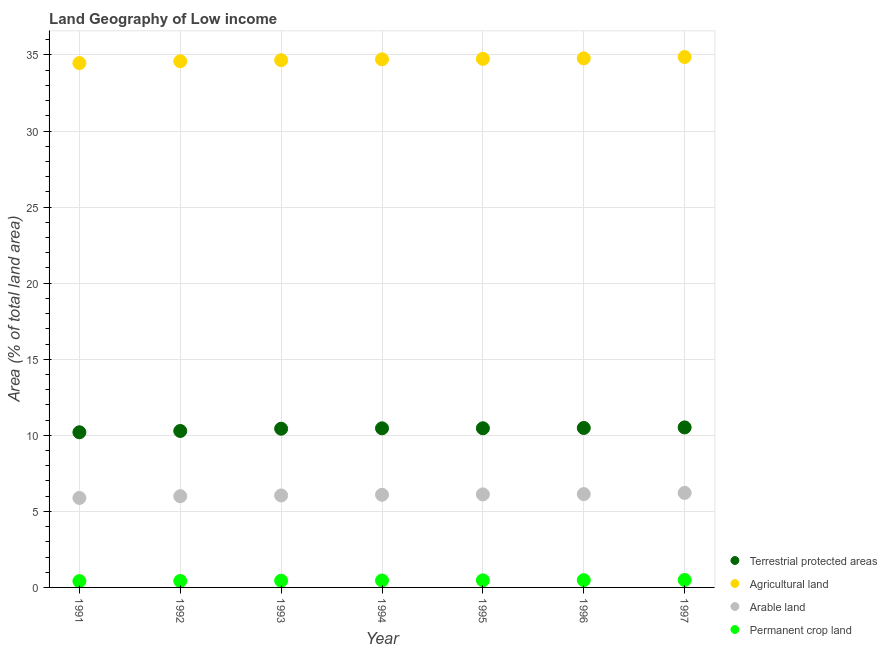How many different coloured dotlines are there?
Provide a short and direct response. 4. Is the number of dotlines equal to the number of legend labels?
Make the answer very short. Yes. What is the percentage of area under permanent crop land in 1996?
Make the answer very short. 0.48. Across all years, what is the maximum percentage of land under terrestrial protection?
Keep it short and to the point. 10.52. Across all years, what is the minimum percentage of area under permanent crop land?
Make the answer very short. 0.41. In which year was the percentage of land under terrestrial protection maximum?
Offer a very short reply. 1997. In which year was the percentage of area under arable land minimum?
Provide a short and direct response. 1991. What is the total percentage of area under permanent crop land in the graph?
Your response must be concise. 3.17. What is the difference between the percentage of land under terrestrial protection in 1992 and that in 1997?
Offer a terse response. -0.23. What is the difference between the percentage of area under permanent crop land in 1991 and the percentage of area under arable land in 1995?
Make the answer very short. -5.7. What is the average percentage of area under arable land per year?
Offer a terse response. 6.07. In the year 1991, what is the difference between the percentage of land under terrestrial protection and percentage of area under permanent crop land?
Your answer should be very brief. 9.78. In how many years, is the percentage of area under arable land greater than 14 %?
Your answer should be very brief. 0. What is the ratio of the percentage of area under agricultural land in 1992 to that in 1994?
Your answer should be very brief. 1. Is the difference between the percentage of area under arable land in 1994 and 1995 greater than the difference between the percentage of land under terrestrial protection in 1994 and 1995?
Offer a terse response. No. What is the difference between the highest and the second highest percentage of area under permanent crop land?
Provide a short and direct response. 0.01. What is the difference between the highest and the lowest percentage of area under agricultural land?
Offer a terse response. 0.4. In how many years, is the percentage of area under arable land greater than the average percentage of area under arable land taken over all years?
Give a very brief answer. 4. Is it the case that in every year, the sum of the percentage of land under terrestrial protection and percentage of area under arable land is greater than the sum of percentage of area under agricultural land and percentage of area under permanent crop land?
Keep it short and to the point. No. Does the percentage of area under arable land monotonically increase over the years?
Provide a short and direct response. Yes. How many years are there in the graph?
Keep it short and to the point. 7. What is the difference between two consecutive major ticks on the Y-axis?
Ensure brevity in your answer.  5. Are the values on the major ticks of Y-axis written in scientific E-notation?
Your response must be concise. No. How are the legend labels stacked?
Your response must be concise. Vertical. What is the title of the graph?
Your answer should be compact. Land Geography of Low income. What is the label or title of the X-axis?
Offer a very short reply. Year. What is the label or title of the Y-axis?
Ensure brevity in your answer.  Area (% of total land area). What is the Area (% of total land area) in Terrestrial protected areas in 1991?
Provide a short and direct response. 10.2. What is the Area (% of total land area) of Agricultural land in 1991?
Ensure brevity in your answer.  34.47. What is the Area (% of total land area) of Arable land in 1991?
Your response must be concise. 5.88. What is the Area (% of total land area) of Permanent crop land in 1991?
Ensure brevity in your answer.  0.41. What is the Area (% of total land area) in Terrestrial protected areas in 1992?
Keep it short and to the point. 10.28. What is the Area (% of total land area) in Agricultural land in 1992?
Keep it short and to the point. 34.59. What is the Area (% of total land area) in Arable land in 1992?
Your answer should be compact. 6. What is the Area (% of total land area) in Permanent crop land in 1992?
Ensure brevity in your answer.  0.42. What is the Area (% of total land area) in Terrestrial protected areas in 1993?
Keep it short and to the point. 10.43. What is the Area (% of total land area) of Agricultural land in 1993?
Make the answer very short. 34.66. What is the Area (% of total land area) of Arable land in 1993?
Your answer should be compact. 6.04. What is the Area (% of total land area) of Permanent crop land in 1993?
Your response must be concise. 0.44. What is the Area (% of total land area) of Terrestrial protected areas in 1994?
Offer a very short reply. 10.46. What is the Area (% of total land area) of Agricultural land in 1994?
Your response must be concise. 34.71. What is the Area (% of total land area) of Arable land in 1994?
Your response must be concise. 6.09. What is the Area (% of total land area) of Permanent crop land in 1994?
Your answer should be very brief. 0.46. What is the Area (% of total land area) in Terrestrial protected areas in 1995?
Your response must be concise. 10.46. What is the Area (% of total land area) of Agricultural land in 1995?
Your response must be concise. 34.74. What is the Area (% of total land area) in Arable land in 1995?
Offer a terse response. 6.11. What is the Area (% of total land area) of Permanent crop land in 1995?
Provide a succinct answer. 0.47. What is the Area (% of total land area) of Terrestrial protected areas in 1996?
Give a very brief answer. 10.48. What is the Area (% of total land area) in Agricultural land in 1996?
Give a very brief answer. 34.77. What is the Area (% of total land area) of Arable land in 1996?
Make the answer very short. 6.13. What is the Area (% of total land area) of Permanent crop land in 1996?
Offer a terse response. 0.48. What is the Area (% of total land area) of Terrestrial protected areas in 1997?
Your answer should be compact. 10.52. What is the Area (% of total land area) of Agricultural land in 1997?
Keep it short and to the point. 34.86. What is the Area (% of total land area) in Arable land in 1997?
Your answer should be very brief. 6.21. What is the Area (% of total land area) in Permanent crop land in 1997?
Make the answer very short. 0.49. Across all years, what is the maximum Area (% of total land area) of Terrestrial protected areas?
Offer a very short reply. 10.52. Across all years, what is the maximum Area (% of total land area) of Agricultural land?
Give a very brief answer. 34.86. Across all years, what is the maximum Area (% of total land area) in Arable land?
Offer a terse response. 6.21. Across all years, what is the maximum Area (% of total land area) in Permanent crop land?
Give a very brief answer. 0.49. Across all years, what is the minimum Area (% of total land area) of Terrestrial protected areas?
Ensure brevity in your answer.  10.2. Across all years, what is the minimum Area (% of total land area) in Agricultural land?
Make the answer very short. 34.47. Across all years, what is the minimum Area (% of total land area) of Arable land?
Offer a very short reply. 5.88. Across all years, what is the minimum Area (% of total land area) of Permanent crop land?
Give a very brief answer. 0.41. What is the total Area (% of total land area) of Terrestrial protected areas in the graph?
Ensure brevity in your answer.  72.84. What is the total Area (% of total land area) of Agricultural land in the graph?
Ensure brevity in your answer.  242.81. What is the total Area (% of total land area) of Arable land in the graph?
Your answer should be compact. 42.48. What is the total Area (% of total land area) in Permanent crop land in the graph?
Offer a terse response. 3.17. What is the difference between the Area (% of total land area) of Terrestrial protected areas in 1991 and that in 1992?
Make the answer very short. -0.09. What is the difference between the Area (% of total land area) in Agricultural land in 1991 and that in 1992?
Give a very brief answer. -0.12. What is the difference between the Area (% of total land area) in Arable land in 1991 and that in 1992?
Provide a succinct answer. -0.11. What is the difference between the Area (% of total land area) in Permanent crop land in 1991 and that in 1992?
Offer a very short reply. -0.01. What is the difference between the Area (% of total land area) of Terrestrial protected areas in 1991 and that in 1993?
Give a very brief answer. -0.23. What is the difference between the Area (% of total land area) of Agricultural land in 1991 and that in 1993?
Ensure brevity in your answer.  -0.19. What is the difference between the Area (% of total land area) of Arable land in 1991 and that in 1993?
Provide a short and direct response. -0.16. What is the difference between the Area (% of total land area) of Permanent crop land in 1991 and that in 1993?
Your answer should be compact. -0.03. What is the difference between the Area (% of total land area) in Terrestrial protected areas in 1991 and that in 1994?
Make the answer very short. -0.26. What is the difference between the Area (% of total land area) in Agricultural land in 1991 and that in 1994?
Your answer should be compact. -0.25. What is the difference between the Area (% of total land area) in Arable land in 1991 and that in 1994?
Your answer should be compact. -0.21. What is the difference between the Area (% of total land area) in Permanent crop land in 1991 and that in 1994?
Your answer should be compact. -0.04. What is the difference between the Area (% of total land area) in Terrestrial protected areas in 1991 and that in 1995?
Offer a very short reply. -0.26. What is the difference between the Area (% of total land area) of Agricultural land in 1991 and that in 1995?
Give a very brief answer. -0.28. What is the difference between the Area (% of total land area) in Arable land in 1991 and that in 1995?
Keep it short and to the point. -0.23. What is the difference between the Area (% of total land area) in Permanent crop land in 1991 and that in 1995?
Your answer should be very brief. -0.05. What is the difference between the Area (% of total land area) of Terrestrial protected areas in 1991 and that in 1996?
Offer a terse response. -0.28. What is the difference between the Area (% of total land area) of Agricultural land in 1991 and that in 1996?
Provide a short and direct response. -0.31. What is the difference between the Area (% of total land area) of Arable land in 1991 and that in 1996?
Make the answer very short. -0.25. What is the difference between the Area (% of total land area) of Permanent crop land in 1991 and that in 1996?
Ensure brevity in your answer.  -0.06. What is the difference between the Area (% of total land area) of Terrestrial protected areas in 1991 and that in 1997?
Give a very brief answer. -0.32. What is the difference between the Area (% of total land area) of Agricultural land in 1991 and that in 1997?
Your response must be concise. -0.4. What is the difference between the Area (% of total land area) of Arable land in 1991 and that in 1997?
Your response must be concise. -0.33. What is the difference between the Area (% of total land area) of Permanent crop land in 1991 and that in 1997?
Give a very brief answer. -0.07. What is the difference between the Area (% of total land area) of Terrestrial protected areas in 1992 and that in 1993?
Keep it short and to the point. -0.15. What is the difference between the Area (% of total land area) of Agricultural land in 1992 and that in 1993?
Offer a very short reply. -0.07. What is the difference between the Area (% of total land area) of Arable land in 1992 and that in 1993?
Your response must be concise. -0.05. What is the difference between the Area (% of total land area) in Permanent crop land in 1992 and that in 1993?
Offer a very short reply. -0.02. What is the difference between the Area (% of total land area) of Terrestrial protected areas in 1992 and that in 1994?
Keep it short and to the point. -0.17. What is the difference between the Area (% of total land area) of Agricultural land in 1992 and that in 1994?
Provide a succinct answer. -0.13. What is the difference between the Area (% of total land area) of Arable land in 1992 and that in 1994?
Offer a very short reply. -0.1. What is the difference between the Area (% of total land area) of Permanent crop land in 1992 and that in 1994?
Offer a terse response. -0.03. What is the difference between the Area (% of total land area) of Terrestrial protected areas in 1992 and that in 1995?
Keep it short and to the point. -0.18. What is the difference between the Area (% of total land area) in Agricultural land in 1992 and that in 1995?
Provide a succinct answer. -0.16. What is the difference between the Area (% of total land area) of Arable land in 1992 and that in 1995?
Ensure brevity in your answer.  -0.12. What is the difference between the Area (% of total land area) of Permanent crop land in 1992 and that in 1995?
Your response must be concise. -0.04. What is the difference between the Area (% of total land area) of Terrestrial protected areas in 1992 and that in 1996?
Provide a succinct answer. -0.2. What is the difference between the Area (% of total land area) in Agricultural land in 1992 and that in 1996?
Offer a very short reply. -0.19. What is the difference between the Area (% of total land area) of Arable land in 1992 and that in 1996?
Ensure brevity in your answer.  -0.14. What is the difference between the Area (% of total land area) of Permanent crop land in 1992 and that in 1996?
Provide a short and direct response. -0.06. What is the difference between the Area (% of total land area) of Terrestrial protected areas in 1992 and that in 1997?
Provide a short and direct response. -0.23. What is the difference between the Area (% of total land area) in Agricultural land in 1992 and that in 1997?
Your response must be concise. -0.28. What is the difference between the Area (% of total land area) of Arable land in 1992 and that in 1997?
Give a very brief answer. -0.22. What is the difference between the Area (% of total land area) in Permanent crop land in 1992 and that in 1997?
Make the answer very short. -0.07. What is the difference between the Area (% of total land area) of Terrestrial protected areas in 1993 and that in 1994?
Your response must be concise. -0.02. What is the difference between the Area (% of total land area) of Agricultural land in 1993 and that in 1994?
Your answer should be compact. -0.06. What is the difference between the Area (% of total land area) of Arable land in 1993 and that in 1994?
Offer a very short reply. -0.05. What is the difference between the Area (% of total land area) of Permanent crop land in 1993 and that in 1994?
Your answer should be very brief. -0.01. What is the difference between the Area (% of total land area) in Terrestrial protected areas in 1993 and that in 1995?
Offer a very short reply. -0.03. What is the difference between the Area (% of total land area) of Agricultural land in 1993 and that in 1995?
Provide a succinct answer. -0.09. What is the difference between the Area (% of total land area) of Arable land in 1993 and that in 1995?
Provide a short and direct response. -0.07. What is the difference between the Area (% of total land area) of Permanent crop land in 1993 and that in 1995?
Offer a very short reply. -0.02. What is the difference between the Area (% of total land area) in Terrestrial protected areas in 1993 and that in 1996?
Offer a terse response. -0.05. What is the difference between the Area (% of total land area) of Agricultural land in 1993 and that in 1996?
Your answer should be very brief. -0.12. What is the difference between the Area (% of total land area) of Arable land in 1993 and that in 1996?
Offer a terse response. -0.09. What is the difference between the Area (% of total land area) in Permanent crop land in 1993 and that in 1996?
Your response must be concise. -0.03. What is the difference between the Area (% of total land area) in Terrestrial protected areas in 1993 and that in 1997?
Keep it short and to the point. -0.09. What is the difference between the Area (% of total land area) of Agricultural land in 1993 and that in 1997?
Provide a short and direct response. -0.21. What is the difference between the Area (% of total land area) in Arable land in 1993 and that in 1997?
Give a very brief answer. -0.17. What is the difference between the Area (% of total land area) in Permanent crop land in 1993 and that in 1997?
Provide a short and direct response. -0.04. What is the difference between the Area (% of total land area) in Terrestrial protected areas in 1994 and that in 1995?
Your answer should be compact. -0. What is the difference between the Area (% of total land area) of Agricultural land in 1994 and that in 1995?
Provide a succinct answer. -0.03. What is the difference between the Area (% of total land area) in Arable land in 1994 and that in 1995?
Provide a succinct answer. -0.02. What is the difference between the Area (% of total land area) in Permanent crop land in 1994 and that in 1995?
Make the answer very short. -0.01. What is the difference between the Area (% of total land area) of Terrestrial protected areas in 1994 and that in 1996?
Your response must be concise. -0.02. What is the difference between the Area (% of total land area) of Agricultural land in 1994 and that in 1996?
Offer a terse response. -0.06. What is the difference between the Area (% of total land area) in Arable land in 1994 and that in 1996?
Your response must be concise. -0.04. What is the difference between the Area (% of total land area) of Permanent crop land in 1994 and that in 1996?
Provide a succinct answer. -0.02. What is the difference between the Area (% of total land area) in Terrestrial protected areas in 1994 and that in 1997?
Your response must be concise. -0.06. What is the difference between the Area (% of total land area) in Agricultural land in 1994 and that in 1997?
Make the answer very short. -0.15. What is the difference between the Area (% of total land area) of Arable land in 1994 and that in 1997?
Your response must be concise. -0.12. What is the difference between the Area (% of total land area) of Permanent crop land in 1994 and that in 1997?
Make the answer very short. -0.03. What is the difference between the Area (% of total land area) of Terrestrial protected areas in 1995 and that in 1996?
Your answer should be compact. -0.02. What is the difference between the Area (% of total land area) of Agricultural land in 1995 and that in 1996?
Give a very brief answer. -0.03. What is the difference between the Area (% of total land area) in Arable land in 1995 and that in 1996?
Keep it short and to the point. -0.02. What is the difference between the Area (% of total land area) of Permanent crop land in 1995 and that in 1996?
Give a very brief answer. -0.01. What is the difference between the Area (% of total land area) of Terrestrial protected areas in 1995 and that in 1997?
Your answer should be compact. -0.06. What is the difference between the Area (% of total land area) in Agricultural land in 1995 and that in 1997?
Give a very brief answer. -0.12. What is the difference between the Area (% of total land area) of Arable land in 1995 and that in 1997?
Provide a succinct answer. -0.1. What is the difference between the Area (% of total land area) in Permanent crop land in 1995 and that in 1997?
Your response must be concise. -0.02. What is the difference between the Area (% of total land area) in Terrestrial protected areas in 1996 and that in 1997?
Offer a terse response. -0.04. What is the difference between the Area (% of total land area) in Agricultural land in 1996 and that in 1997?
Provide a succinct answer. -0.09. What is the difference between the Area (% of total land area) of Arable land in 1996 and that in 1997?
Offer a very short reply. -0.08. What is the difference between the Area (% of total land area) in Permanent crop land in 1996 and that in 1997?
Offer a very short reply. -0.01. What is the difference between the Area (% of total land area) of Terrestrial protected areas in 1991 and the Area (% of total land area) of Agricultural land in 1992?
Give a very brief answer. -24.39. What is the difference between the Area (% of total land area) in Terrestrial protected areas in 1991 and the Area (% of total land area) in Arable land in 1992?
Make the answer very short. 4.2. What is the difference between the Area (% of total land area) in Terrestrial protected areas in 1991 and the Area (% of total land area) in Permanent crop land in 1992?
Your answer should be compact. 9.78. What is the difference between the Area (% of total land area) in Agricultural land in 1991 and the Area (% of total land area) in Arable land in 1992?
Your answer should be compact. 28.47. What is the difference between the Area (% of total land area) in Agricultural land in 1991 and the Area (% of total land area) in Permanent crop land in 1992?
Provide a succinct answer. 34.05. What is the difference between the Area (% of total land area) of Arable land in 1991 and the Area (% of total land area) of Permanent crop land in 1992?
Keep it short and to the point. 5.46. What is the difference between the Area (% of total land area) in Terrestrial protected areas in 1991 and the Area (% of total land area) in Agricultural land in 1993?
Offer a very short reply. -24.46. What is the difference between the Area (% of total land area) in Terrestrial protected areas in 1991 and the Area (% of total land area) in Arable land in 1993?
Make the answer very short. 4.15. What is the difference between the Area (% of total land area) in Terrestrial protected areas in 1991 and the Area (% of total land area) in Permanent crop land in 1993?
Provide a short and direct response. 9.75. What is the difference between the Area (% of total land area) of Agricultural land in 1991 and the Area (% of total land area) of Arable land in 1993?
Ensure brevity in your answer.  28.42. What is the difference between the Area (% of total land area) of Agricultural land in 1991 and the Area (% of total land area) of Permanent crop land in 1993?
Keep it short and to the point. 34.02. What is the difference between the Area (% of total land area) of Arable land in 1991 and the Area (% of total land area) of Permanent crop land in 1993?
Offer a terse response. 5.44. What is the difference between the Area (% of total land area) of Terrestrial protected areas in 1991 and the Area (% of total land area) of Agricultural land in 1994?
Ensure brevity in your answer.  -24.51. What is the difference between the Area (% of total land area) in Terrestrial protected areas in 1991 and the Area (% of total land area) in Arable land in 1994?
Provide a short and direct response. 4.11. What is the difference between the Area (% of total land area) in Terrestrial protected areas in 1991 and the Area (% of total land area) in Permanent crop land in 1994?
Give a very brief answer. 9.74. What is the difference between the Area (% of total land area) of Agricultural land in 1991 and the Area (% of total land area) of Arable land in 1994?
Give a very brief answer. 28.38. What is the difference between the Area (% of total land area) in Agricultural land in 1991 and the Area (% of total land area) in Permanent crop land in 1994?
Provide a succinct answer. 34.01. What is the difference between the Area (% of total land area) of Arable land in 1991 and the Area (% of total land area) of Permanent crop land in 1994?
Keep it short and to the point. 5.43. What is the difference between the Area (% of total land area) in Terrestrial protected areas in 1991 and the Area (% of total land area) in Agricultural land in 1995?
Offer a terse response. -24.55. What is the difference between the Area (% of total land area) in Terrestrial protected areas in 1991 and the Area (% of total land area) in Arable land in 1995?
Provide a short and direct response. 4.08. What is the difference between the Area (% of total land area) of Terrestrial protected areas in 1991 and the Area (% of total land area) of Permanent crop land in 1995?
Give a very brief answer. 9.73. What is the difference between the Area (% of total land area) in Agricultural land in 1991 and the Area (% of total land area) in Arable land in 1995?
Offer a very short reply. 28.35. What is the difference between the Area (% of total land area) of Agricultural land in 1991 and the Area (% of total land area) of Permanent crop land in 1995?
Offer a very short reply. 34. What is the difference between the Area (% of total land area) in Arable land in 1991 and the Area (% of total land area) in Permanent crop land in 1995?
Make the answer very short. 5.42. What is the difference between the Area (% of total land area) of Terrestrial protected areas in 1991 and the Area (% of total land area) of Agricultural land in 1996?
Offer a very short reply. -24.58. What is the difference between the Area (% of total land area) in Terrestrial protected areas in 1991 and the Area (% of total land area) in Arable land in 1996?
Your response must be concise. 4.07. What is the difference between the Area (% of total land area) in Terrestrial protected areas in 1991 and the Area (% of total land area) in Permanent crop land in 1996?
Keep it short and to the point. 9.72. What is the difference between the Area (% of total land area) of Agricultural land in 1991 and the Area (% of total land area) of Arable land in 1996?
Your response must be concise. 28.33. What is the difference between the Area (% of total land area) of Agricultural land in 1991 and the Area (% of total land area) of Permanent crop land in 1996?
Offer a very short reply. 33.99. What is the difference between the Area (% of total land area) of Arable land in 1991 and the Area (% of total land area) of Permanent crop land in 1996?
Your response must be concise. 5.4. What is the difference between the Area (% of total land area) of Terrestrial protected areas in 1991 and the Area (% of total land area) of Agricultural land in 1997?
Offer a terse response. -24.67. What is the difference between the Area (% of total land area) in Terrestrial protected areas in 1991 and the Area (% of total land area) in Arable land in 1997?
Offer a very short reply. 3.98. What is the difference between the Area (% of total land area) of Terrestrial protected areas in 1991 and the Area (% of total land area) of Permanent crop land in 1997?
Your response must be concise. 9.71. What is the difference between the Area (% of total land area) in Agricultural land in 1991 and the Area (% of total land area) in Arable land in 1997?
Keep it short and to the point. 28.25. What is the difference between the Area (% of total land area) in Agricultural land in 1991 and the Area (% of total land area) in Permanent crop land in 1997?
Keep it short and to the point. 33.98. What is the difference between the Area (% of total land area) of Arable land in 1991 and the Area (% of total land area) of Permanent crop land in 1997?
Offer a very short reply. 5.39. What is the difference between the Area (% of total land area) in Terrestrial protected areas in 1992 and the Area (% of total land area) in Agricultural land in 1993?
Provide a succinct answer. -24.37. What is the difference between the Area (% of total land area) of Terrestrial protected areas in 1992 and the Area (% of total land area) of Arable land in 1993?
Offer a very short reply. 4.24. What is the difference between the Area (% of total land area) in Terrestrial protected areas in 1992 and the Area (% of total land area) in Permanent crop land in 1993?
Keep it short and to the point. 9.84. What is the difference between the Area (% of total land area) in Agricultural land in 1992 and the Area (% of total land area) in Arable land in 1993?
Ensure brevity in your answer.  28.54. What is the difference between the Area (% of total land area) of Agricultural land in 1992 and the Area (% of total land area) of Permanent crop land in 1993?
Your response must be concise. 34.14. What is the difference between the Area (% of total land area) in Arable land in 1992 and the Area (% of total land area) in Permanent crop land in 1993?
Provide a succinct answer. 5.55. What is the difference between the Area (% of total land area) in Terrestrial protected areas in 1992 and the Area (% of total land area) in Agricultural land in 1994?
Offer a very short reply. -24.43. What is the difference between the Area (% of total land area) in Terrestrial protected areas in 1992 and the Area (% of total land area) in Arable land in 1994?
Provide a short and direct response. 4.19. What is the difference between the Area (% of total land area) of Terrestrial protected areas in 1992 and the Area (% of total land area) of Permanent crop land in 1994?
Keep it short and to the point. 9.83. What is the difference between the Area (% of total land area) of Agricultural land in 1992 and the Area (% of total land area) of Arable land in 1994?
Provide a short and direct response. 28.5. What is the difference between the Area (% of total land area) of Agricultural land in 1992 and the Area (% of total land area) of Permanent crop land in 1994?
Ensure brevity in your answer.  34.13. What is the difference between the Area (% of total land area) in Arable land in 1992 and the Area (% of total land area) in Permanent crop land in 1994?
Ensure brevity in your answer.  5.54. What is the difference between the Area (% of total land area) of Terrestrial protected areas in 1992 and the Area (% of total land area) of Agricultural land in 1995?
Your response must be concise. -24.46. What is the difference between the Area (% of total land area) of Terrestrial protected areas in 1992 and the Area (% of total land area) of Arable land in 1995?
Keep it short and to the point. 4.17. What is the difference between the Area (% of total land area) of Terrestrial protected areas in 1992 and the Area (% of total land area) of Permanent crop land in 1995?
Provide a short and direct response. 9.82. What is the difference between the Area (% of total land area) in Agricultural land in 1992 and the Area (% of total land area) in Arable land in 1995?
Your answer should be very brief. 28.47. What is the difference between the Area (% of total land area) in Agricultural land in 1992 and the Area (% of total land area) in Permanent crop land in 1995?
Offer a very short reply. 34.12. What is the difference between the Area (% of total land area) of Arable land in 1992 and the Area (% of total land area) of Permanent crop land in 1995?
Give a very brief answer. 5.53. What is the difference between the Area (% of total land area) of Terrestrial protected areas in 1992 and the Area (% of total land area) of Agricultural land in 1996?
Keep it short and to the point. -24.49. What is the difference between the Area (% of total land area) in Terrestrial protected areas in 1992 and the Area (% of total land area) in Arable land in 1996?
Make the answer very short. 4.15. What is the difference between the Area (% of total land area) in Terrestrial protected areas in 1992 and the Area (% of total land area) in Permanent crop land in 1996?
Offer a terse response. 9.81. What is the difference between the Area (% of total land area) of Agricultural land in 1992 and the Area (% of total land area) of Arable land in 1996?
Your response must be concise. 28.45. What is the difference between the Area (% of total land area) of Agricultural land in 1992 and the Area (% of total land area) of Permanent crop land in 1996?
Provide a succinct answer. 34.11. What is the difference between the Area (% of total land area) in Arable land in 1992 and the Area (% of total land area) in Permanent crop land in 1996?
Offer a very short reply. 5.52. What is the difference between the Area (% of total land area) of Terrestrial protected areas in 1992 and the Area (% of total land area) of Agricultural land in 1997?
Your answer should be very brief. -24.58. What is the difference between the Area (% of total land area) of Terrestrial protected areas in 1992 and the Area (% of total land area) of Arable land in 1997?
Your answer should be compact. 4.07. What is the difference between the Area (% of total land area) of Terrestrial protected areas in 1992 and the Area (% of total land area) of Permanent crop land in 1997?
Your response must be concise. 9.8. What is the difference between the Area (% of total land area) of Agricultural land in 1992 and the Area (% of total land area) of Arable land in 1997?
Ensure brevity in your answer.  28.37. What is the difference between the Area (% of total land area) in Agricultural land in 1992 and the Area (% of total land area) in Permanent crop land in 1997?
Make the answer very short. 34.1. What is the difference between the Area (% of total land area) of Arable land in 1992 and the Area (% of total land area) of Permanent crop land in 1997?
Give a very brief answer. 5.51. What is the difference between the Area (% of total land area) of Terrestrial protected areas in 1993 and the Area (% of total land area) of Agricultural land in 1994?
Provide a short and direct response. -24.28. What is the difference between the Area (% of total land area) of Terrestrial protected areas in 1993 and the Area (% of total land area) of Arable land in 1994?
Give a very brief answer. 4.34. What is the difference between the Area (% of total land area) in Terrestrial protected areas in 1993 and the Area (% of total land area) in Permanent crop land in 1994?
Your answer should be very brief. 9.98. What is the difference between the Area (% of total land area) in Agricultural land in 1993 and the Area (% of total land area) in Arable land in 1994?
Your response must be concise. 28.56. What is the difference between the Area (% of total land area) in Agricultural land in 1993 and the Area (% of total land area) in Permanent crop land in 1994?
Your response must be concise. 34.2. What is the difference between the Area (% of total land area) of Arable land in 1993 and the Area (% of total land area) of Permanent crop land in 1994?
Offer a very short reply. 5.59. What is the difference between the Area (% of total land area) of Terrestrial protected areas in 1993 and the Area (% of total land area) of Agricultural land in 1995?
Offer a terse response. -24.31. What is the difference between the Area (% of total land area) of Terrestrial protected areas in 1993 and the Area (% of total land area) of Arable land in 1995?
Offer a very short reply. 4.32. What is the difference between the Area (% of total land area) in Terrestrial protected areas in 1993 and the Area (% of total land area) in Permanent crop land in 1995?
Your answer should be very brief. 9.97. What is the difference between the Area (% of total land area) of Agricultural land in 1993 and the Area (% of total land area) of Arable land in 1995?
Provide a succinct answer. 28.54. What is the difference between the Area (% of total land area) of Agricultural land in 1993 and the Area (% of total land area) of Permanent crop land in 1995?
Your response must be concise. 34.19. What is the difference between the Area (% of total land area) in Arable land in 1993 and the Area (% of total land area) in Permanent crop land in 1995?
Your response must be concise. 5.58. What is the difference between the Area (% of total land area) in Terrestrial protected areas in 1993 and the Area (% of total land area) in Agricultural land in 1996?
Offer a very short reply. -24.34. What is the difference between the Area (% of total land area) in Terrestrial protected areas in 1993 and the Area (% of total land area) in Arable land in 1996?
Provide a succinct answer. 4.3. What is the difference between the Area (% of total land area) in Terrestrial protected areas in 1993 and the Area (% of total land area) in Permanent crop land in 1996?
Your answer should be very brief. 9.96. What is the difference between the Area (% of total land area) of Agricultural land in 1993 and the Area (% of total land area) of Arable land in 1996?
Offer a terse response. 28.52. What is the difference between the Area (% of total land area) of Agricultural land in 1993 and the Area (% of total land area) of Permanent crop land in 1996?
Keep it short and to the point. 34.18. What is the difference between the Area (% of total land area) in Arable land in 1993 and the Area (% of total land area) in Permanent crop land in 1996?
Offer a very short reply. 5.57. What is the difference between the Area (% of total land area) in Terrestrial protected areas in 1993 and the Area (% of total land area) in Agricultural land in 1997?
Keep it short and to the point. -24.43. What is the difference between the Area (% of total land area) of Terrestrial protected areas in 1993 and the Area (% of total land area) of Arable land in 1997?
Your answer should be very brief. 4.22. What is the difference between the Area (% of total land area) in Terrestrial protected areas in 1993 and the Area (% of total land area) in Permanent crop land in 1997?
Provide a short and direct response. 9.94. What is the difference between the Area (% of total land area) of Agricultural land in 1993 and the Area (% of total land area) of Arable land in 1997?
Offer a very short reply. 28.44. What is the difference between the Area (% of total land area) in Agricultural land in 1993 and the Area (% of total land area) in Permanent crop land in 1997?
Your answer should be very brief. 34.17. What is the difference between the Area (% of total land area) of Arable land in 1993 and the Area (% of total land area) of Permanent crop land in 1997?
Your answer should be compact. 5.56. What is the difference between the Area (% of total land area) in Terrestrial protected areas in 1994 and the Area (% of total land area) in Agricultural land in 1995?
Offer a terse response. -24.29. What is the difference between the Area (% of total land area) of Terrestrial protected areas in 1994 and the Area (% of total land area) of Arable land in 1995?
Provide a short and direct response. 4.34. What is the difference between the Area (% of total land area) in Terrestrial protected areas in 1994 and the Area (% of total land area) in Permanent crop land in 1995?
Ensure brevity in your answer.  9.99. What is the difference between the Area (% of total land area) of Agricultural land in 1994 and the Area (% of total land area) of Arable land in 1995?
Your answer should be compact. 28.6. What is the difference between the Area (% of total land area) of Agricultural land in 1994 and the Area (% of total land area) of Permanent crop land in 1995?
Give a very brief answer. 34.25. What is the difference between the Area (% of total land area) of Arable land in 1994 and the Area (% of total land area) of Permanent crop land in 1995?
Give a very brief answer. 5.63. What is the difference between the Area (% of total land area) in Terrestrial protected areas in 1994 and the Area (% of total land area) in Agricultural land in 1996?
Provide a short and direct response. -24.32. What is the difference between the Area (% of total land area) of Terrestrial protected areas in 1994 and the Area (% of total land area) of Arable land in 1996?
Ensure brevity in your answer.  4.32. What is the difference between the Area (% of total land area) of Terrestrial protected areas in 1994 and the Area (% of total land area) of Permanent crop land in 1996?
Give a very brief answer. 9.98. What is the difference between the Area (% of total land area) in Agricultural land in 1994 and the Area (% of total land area) in Arable land in 1996?
Provide a short and direct response. 28.58. What is the difference between the Area (% of total land area) in Agricultural land in 1994 and the Area (% of total land area) in Permanent crop land in 1996?
Your answer should be compact. 34.24. What is the difference between the Area (% of total land area) in Arable land in 1994 and the Area (% of total land area) in Permanent crop land in 1996?
Ensure brevity in your answer.  5.61. What is the difference between the Area (% of total land area) in Terrestrial protected areas in 1994 and the Area (% of total land area) in Agricultural land in 1997?
Your answer should be compact. -24.41. What is the difference between the Area (% of total land area) in Terrestrial protected areas in 1994 and the Area (% of total land area) in Arable land in 1997?
Provide a short and direct response. 4.24. What is the difference between the Area (% of total land area) in Terrestrial protected areas in 1994 and the Area (% of total land area) in Permanent crop land in 1997?
Provide a succinct answer. 9.97. What is the difference between the Area (% of total land area) in Agricultural land in 1994 and the Area (% of total land area) in Arable land in 1997?
Your response must be concise. 28.5. What is the difference between the Area (% of total land area) in Agricultural land in 1994 and the Area (% of total land area) in Permanent crop land in 1997?
Offer a terse response. 34.23. What is the difference between the Area (% of total land area) in Arable land in 1994 and the Area (% of total land area) in Permanent crop land in 1997?
Make the answer very short. 5.6. What is the difference between the Area (% of total land area) of Terrestrial protected areas in 1995 and the Area (% of total land area) of Agricultural land in 1996?
Provide a short and direct response. -24.31. What is the difference between the Area (% of total land area) of Terrestrial protected areas in 1995 and the Area (% of total land area) of Arable land in 1996?
Offer a terse response. 4.33. What is the difference between the Area (% of total land area) of Terrestrial protected areas in 1995 and the Area (% of total land area) of Permanent crop land in 1996?
Provide a short and direct response. 9.98. What is the difference between the Area (% of total land area) in Agricultural land in 1995 and the Area (% of total land area) in Arable land in 1996?
Your answer should be compact. 28.61. What is the difference between the Area (% of total land area) of Agricultural land in 1995 and the Area (% of total land area) of Permanent crop land in 1996?
Offer a terse response. 34.27. What is the difference between the Area (% of total land area) of Arable land in 1995 and the Area (% of total land area) of Permanent crop land in 1996?
Provide a short and direct response. 5.64. What is the difference between the Area (% of total land area) in Terrestrial protected areas in 1995 and the Area (% of total land area) in Agricultural land in 1997?
Your response must be concise. -24.4. What is the difference between the Area (% of total land area) of Terrestrial protected areas in 1995 and the Area (% of total land area) of Arable land in 1997?
Provide a short and direct response. 4.25. What is the difference between the Area (% of total land area) of Terrestrial protected areas in 1995 and the Area (% of total land area) of Permanent crop land in 1997?
Offer a terse response. 9.97. What is the difference between the Area (% of total land area) in Agricultural land in 1995 and the Area (% of total land area) in Arable land in 1997?
Ensure brevity in your answer.  28.53. What is the difference between the Area (% of total land area) in Agricultural land in 1995 and the Area (% of total land area) in Permanent crop land in 1997?
Offer a terse response. 34.26. What is the difference between the Area (% of total land area) in Arable land in 1995 and the Area (% of total land area) in Permanent crop land in 1997?
Offer a terse response. 5.63. What is the difference between the Area (% of total land area) of Terrestrial protected areas in 1996 and the Area (% of total land area) of Agricultural land in 1997?
Provide a succinct answer. -24.38. What is the difference between the Area (% of total land area) of Terrestrial protected areas in 1996 and the Area (% of total land area) of Arable land in 1997?
Your answer should be compact. 4.27. What is the difference between the Area (% of total land area) in Terrestrial protected areas in 1996 and the Area (% of total land area) in Permanent crop land in 1997?
Make the answer very short. 9.99. What is the difference between the Area (% of total land area) of Agricultural land in 1996 and the Area (% of total land area) of Arable land in 1997?
Keep it short and to the point. 28.56. What is the difference between the Area (% of total land area) in Agricultural land in 1996 and the Area (% of total land area) in Permanent crop land in 1997?
Give a very brief answer. 34.29. What is the difference between the Area (% of total land area) in Arable land in 1996 and the Area (% of total land area) in Permanent crop land in 1997?
Ensure brevity in your answer.  5.64. What is the average Area (% of total land area) in Terrestrial protected areas per year?
Your answer should be compact. 10.41. What is the average Area (% of total land area) of Agricultural land per year?
Your response must be concise. 34.69. What is the average Area (% of total land area) in Arable land per year?
Make the answer very short. 6.07. What is the average Area (% of total land area) in Permanent crop land per year?
Offer a very short reply. 0.45. In the year 1991, what is the difference between the Area (% of total land area) in Terrestrial protected areas and Area (% of total land area) in Agricultural land?
Keep it short and to the point. -24.27. In the year 1991, what is the difference between the Area (% of total land area) of Terrestrial protected areas and Area (% of total land area) of Arable land?
Offer a very short reply. 4.32. In the year 1991, what is the difference between the Area (% of total land area) in Terrestrial protected areas and Area (% of total land area) in Permanent crop land?
Offer a terse response. 9.78. In the year 1991, what is the difference between the Area (% of total land area) in Agricultural land and Area (% of total land area) in Arable land?
Your response must be concise. 28.59. In the year 1991, what is the difference between the Area (% of total land area) in Agricultural land and Area (% of total land area) in Permanent crop land?
Ensure brevity in your answer.  34.05. In the year 1991, what is the difference between the Area (% of total land area) of Arable land and Area (% of total land area) of Permanent crop land?
Offer a terse response. 5.47. In the year 1992, what is the difference between the Area (% of total land area) in Terrestrial protected areas and Area (% of total land area) in Agricultural land?
Keep it short and to the point. -24.3. In the year 1992, what is the difference between the Area (% of total land area) in Terrestrial protected areas and Area (% of total land area) in Arable land?
Your answer should be very brief. 4.29. In the year 1992, what is the difference between the Area (% of total land area) of Terrestrial protected areas and Area (% of total land area) of Permanent crop land?
Offer a terse response. 9.86. In the year 1992, what is the difference between the Area (% of total land area) of Agricultural land and Area (% of total land area) of Arable land?
Offer a terse response. 28.59. In the year 1992, what is the difference between the Area (% of total land area) in Agricultural land and Area (% of total land area) in Permanent crop land?
Your response must be concise. 34.17. In the year 1992, what is the difference between the Area (% of total land area) in Arable land and Area (% of total land area) in Permanent crop land?
Keep it short and to the point. 5.57. In the year 1993, what is the difference between the Area (% of total land area) of Terrestrial protected areas and Area (% of total land area) of Agricultural land?
Ensure brevity in your answer.  -24.22. In the year 1993, what is the difference between the Area (% of total land area) of Terrestrial protected areas and Area (% of total land area) of Arable land?
Offer a terse response. 4.39. In the year 1993, what is the difference between the Area (% of total land area) of Terrestrial protected areas and Area (% of total land area) of Permanent crop land?
Make the answer very short. 9.99. In the year 1993, what is the difference between the Area (% of total land area) in Agricultural land and Area (% of total land area) in Arable land?
Make the answer very short. 28.61. In the year 1993, what is the difference between the Area (% of total land area) of Agricultural land and Area (% of total land area) of Permanent crop land?
Make the answer very short. 34.21. In the year 1993, what is the difference between the Area (% of total land area) in Arable land and Area (% of total land area) in Permanent crop land?
Ensure brevity in your answer.  5.6. In the year 1994, what is the difference between the Area (% of total land area) in Terrestrial protected areas and Area (% of total land area) in Agricultural land?
Your response must be concise. -24.26. In the year 1994, what is the difference between the Area (% of total land area) in Terrestrial protected areas and Area (% of total land area) in Arable land?
Keep it short and to the point. 4.37. In the year 1994, what is the difference between the Area (% of total land area) of Terrestrial protected areas and Area (% of total land area) of Permanent crop land?
Provide a succinct answer. 10. In the year 1994, what is the difference between the Area (% of total land area) of Agricultural land and Area (% of total land area) of Arable land?
Make the answer very short. 28.62. In the year 1994, what is the difference between the Area (% of total land area) of Agricultural land and Area (% of total land area) of Permanent crop land?
Ensure brevity in your answer.  34.26. In the year 1994, what is the difference between the Area (% of total land area) in Arable land and Area (% of total land area) in Permanent crop land?
Your answer should be compact. 5.64. In the year 1995, what is the difference between the Area (% of total land area) of Terrestrial protected areas and Area (% of total land area) of Agricultural land?
Give a very brief answer. -24.28. In the year 1995, what is the difference between the Area (% of total land area) of Terrestrial protected areas and Area (% of total land area) of Arable land?
Your answer should be compact. 4.35. In the year 1995, what is the difference between the Area (% of total land area) in Terrestrial protected areas and Area (% of total land area) in Permanent crop land?
Make the answer very short. 10. In the year 1995, what is the difference between the Area (% of total land area) of Agricultural land and Area (% of total land area) of Arable land?
Offer a very short reply. 28.63. In the year 1995, what is the difference between the Area (% of total land area) in Agricultural land and Area (% of total land area) in Permanent crop land?
Your response must be concise. 34.28. In the year 1995, what is the difference between the Area (% of total land area) in Arable land and Area (% of total land area) in Permanent crop land?
Provide a succinct answer. 5.65. In the year 1996, what is the difference between the Area (% of total land area) in Terrestrial protected areas and Area (% of total land area) in Agricultural land?
Your answer should be compact. -24.29. In the year 1996, what is the difference between the Area (% of total land area) of Terrestrial protected areas and Area (% of total land area) of Arable land?
Make the answer very short. 4.35. In the year 1996, what is the difference between the Area (% of total land area) in Terrestrial protected areas and Area (% of total land area) in Permanent crop land?
Offer a very short reply. 10. In the year 1996, what is the difference between the Area (% of total land area) in Agricultural land and Area (% of total land area) in Arable land?
Your answer should be very brief. 28.64. In the year 1996, what is the difference between the Area (% of total land area) of Agricultural land and Area (% of total land area) of Permanent crop land?
Keep it short and to the point. 34.3. In the year 1996, what is the difference between the Area (% of total land area) in Arable land and Area (% of total land area) in Permanent crop land?
Your response must be concise. 5.66. In the year 1997, what is the difference between the Area (% of total land area) in Terrestrial protected areas and Area (% of total land area) in Agricultural land?
Offer a very short reply. -24.35. In the year 1997, what is the difference between the Area (% of total land area) in Terrestrial protected areas and Area (% of total land area) in Arable land?
Offer a very short reply. 4.3. In the year 1997, what is the difference between the Area (% of total land area) of Terrestrial protected areas and Area (% of total land area) of Permanent crop land?
Make the answer very short. 10.03. In the year 1997, what is the difference between the Area (% of total land area) in Agricultural land and Area (% of total land area) in Arable land?
Provide a succinct answer. 28.65. In the year 1997, what is the difference between the Area (% of total land area) of Agricultural land and Area (% of total land area) of Permanent crop land?
Offer a terse response. 34.38. In the year 1997, what is the difference between the Area (% of total land area) of Arable land and Area (% of total land area) of Permanent crop land?
Keep it short and to the point. 5.73. What is the ratio of the Area (% of total land area) of Agricultural land in 1991 to that in 1992?
Make the answer very short. 1. What is the ratio of the Area (% of total land area) in Arable land in 1991 to that in 1992?
Your answer should be very brief. 0.98. What is the ratio of the Area (% of total land area) in Terrestrial protected areas in 1991 to that in 1993?
Provide a short and direct response. 0.98. What is the ratio of the Area (% of total land area) in Agricultural land in 1991 to that in 1993?
Your response must be concise. 0.99. What is the ratio of the Area (% of total land area) in Arable land in 1991 to that in 1993?
Ensure brevity in your answer.  0.97. What is the ratio of the Area (% of total land area) in Permanent crop land in 1991 to that in 1993?
Your answer should be very brief. 0.93. What is the ratio of the Area (% of total land area) of Terrestrial protected areas in 1991 to that in 1994?
Offer a terse response. 0.98. What is the ratio of the Area (% of total land area) of Arable land in 1991 to that in 1994?
Your response must be concise. 0.97. What is the ratio of the Area (% of total land area) in Permanent crop land in 1991 to that in 1994?
Your answer should be very brief. 0.91. What is the ratio of the Area (% of total land area) of Terrestrial protected areas in 1991 to that in 1995?
Provide a succinct answer. 0.97. What is the ratio of the Area (% of total land area) in Agricultural land in 1991 to that in 1995?
Ensure brevity in your answer.  0.99. What is the ratio of the Area (% of total land area) of Arable land in 1991 to that in 1995?
Keep it short and to the point. 0.96. What is the ratio of the Area (% of total land area) of Permanent crop land in 1991 to that in 1995?
Provide a succinct answer. 0.89. What is the ratio of the Area (% of total land area) of Agricultural land in 1991 to that in 1996?
Offer a very short reply. 0.99. What is the ratio of the Area (% of total land area) in Arable land in 1991 to that in 1996?
Provide a short and direct response. 0.96. What is the ratio of the Area (% of total land area) in Permanent crop land in 1991 to that in 1996?
Provide a succinct answer. 0.87. What is the ratio of the Area (% of total land area) in Terrestrial protected areas in 1991 to that in 1997?
Provide a succinct answer. 0.97. What is the ratio of the Area (% of total land area) in Agricultural land in 1991 to that in 1997?
Your answer should be compact. 0.99. What is the ratio of the Area (% of total land area) of Arable land in 1991 to that in 1997?
Your answer should be very brief. 0.95. What is the ratio of the Area (% of total land area) of Permanent crop land in 1991 to that in 1997?
Your answer should be very brief. 0.85. What is the ratio of the Area (% of total land area) in Terrestrial protected areas in 1992 to that in 1993?
Your answer should be very brief. 0.99. What is the ratio of the Area (% of total land area) in Terrestrial protected areas in 1992 to that in 1994?
Ensure brevity in your answer.  0.98. What is the ratio of the Area (% of total land area) in Agricultural land in 1992 to that in 1994?
Your response must be concise. 1. What is the ratio of the Area (% of total land area) of Arable land in 1992 to that in 1994?
Your answer should be very brief. 0.98. What is the ratio of the Area (% of total land area) in Permanent crop land in 1992 to that in 1994?
Provide a short and direct response. 0.93. What is the ratio of the Area (% of total land area) in Terrestrial protected areas in 1992 to that in 1995?
Ensure brevity in your answer.  0.98. What is the ratio of the Area (% of total land area) in Agricultural land in 1992 to that in 1995?
Make the answer very short. 1. What is the ratio of the Area (% of total land area) of Arable land in 1992 to that in 1995?
Your answer should be very brief. 0.98. What is the ratio of the Area (% of total land area) in Permanent crop land in 1992 to that in 1995?
Provide a short and direct response. 0.91. What is the ratio of the Area (% of total land area) of Terrestrial protected areas in 1992 to that in 1996?
Your answer should be very brief. 0.98. What is the ratio of the Area (% of total land area) of Arable land in 1992 to that in 1996?
Your answer should be compact. 0.98. What is the ratio of the Area (% of total land area) in Permanent crop land in 1992 to that in 1996?
Your answer should be compact. 0.88. What is the ratio of the Area (% of total land area) of Terrestrial protected areas in 1992 to that in 1997?
Give a very brief answer. 0.98. What is the ratio of the Area (% of total land area) of Agricultural land in 1992 to that in 1997?
Ensure brevity in your answer.  0.99. What is the ratio of the Area (% of total land area) of Arable land in 1992 to that in 1997?
Provide a succinct answer. 0.96. What is the ratio of the Area (% of total land area) of Permanent crop land in 1992 to that in 1997?
Offer a terse response. 0.86. What is the ratio of the Area (% of total land area) in Arable land in 1993 to that in 1994?
Make the answer very short. 0.99. What is the ratio of the Area (% of total land area) of Permanent crop land in 1993 to that in 1994?
Your answer should be very brief. 0.97. What is the ratio of the Area (% of total land area) in Arable land in 1993 to that in 1995?
Your answer should be compact. 0.99. What is the ratio of the Area (% of total land area) of Permanent crop land in 1993 to that in 1995?
Your answer should be very brief. 0.95. What is the ratio of the Area (% of total land area) of Agricultural land in 1993 to that in 1996?
Give a very brief answer. 1. What is the ratio of the Area (% of total land area) of Arable land in 1993 to that in 1996?
Your answer should be very brief. 0.99. What is the ratio of the Area (% of total land area) of Arable land in 1993 to that in 1997?
Give a very brief answer. 0.97. What is the ratio of the Area (% of total land area) of Permanent crop land in 1993 to that in 1997?
Ensure brevity in your answer.  0.91. What is the ratio of the Area (% of total land area) of Terrestrial protected areas in 1994 to that in 1995?
Provide a short and direct response. 1. What is the ratio of the Area (% of total land area) of Agricultural land in 1994 to that in 1995?
Provide a short and direct response. 1. What is the ratio of the Area (% of total land area) of Arable land in 1994 to that in 1995?
Your response must be concise. 1. What is the ratio of the Area (% of total land area) in Permanent crop land in 1994 to that in 1995?
Ensure brevity in your answer.  0.98. What is the ratio of the Area (% of total land area) of Terrestrial protected areas in 1994 to that in 1996?
Your answer should be compact. 1. What is the ratio of the Area (% of total land area) in Permanent crop land in 1994 to that in 1996?
Your answer should be compact. 0.95. What is the ratio of the Area (% of total land area) in Agricultural land in 1994 to that in 1997?
Your answer should be compact. 1. What is the ratio of the Area (% of total land area) of Arable land in 1994 to that in 1997?
Provide a succinct answer. 0.98. What is the ratio of the Area (% of total land area) in Permanent crop land in 1994 to that in 1997?
Offer a very short reply. 0.93. What is the ratio of the Area (% of total land area) in Agricultural land in 1995 to that in 1996?
Offer a very short reply. 1. What is the ratio of the Area (% of total land area) in Permanent crop land in 1995 to that in 1996?
Provide a short and direct response. 0.97. What is the ratio of the Area (% of total land area) of Terrestrial protected areas in 1995 to that in 1997?
Provide a short and direct response. 0.99. What is the ratio of the Area (% of total land area) in Agricultural land in 1995 to that in 1997?
Make the answer very short. 1. What is the ratio of the Area (% of total land area) in Arable land in 1995 to that in 1997?
Your answer should be compact. 0.98. What is the ratio of the Area (% of total land area) in Permanent crop land in 1995 to that in 1997?
Ensure brevity in your answer.  0.95. What is the ratio of the Area (% of total land area) of Terrestrial protected areas in 1996 to that in 1997?
Provide a short and direct response. 1. What is the ratio of the Area (% of total land area) in Arable land in 1996 to that in 1997?
Your answer should be very brief. 0.99. What is the ratio of the Area (% of total land area) in Permanent crop land in 1996 to that in 1997?
Give a very brief answer. 0.98. What is the difference between the highest and the second highest Area (% of total land area) of Terrestrial protected areas?
Offer a very short reply. 0.04. What is the difference between the highest and the second highest Area (% of total land area) in Agricultural land?
Ensure brevity in your answer.  0.09. What is the difference between the highest and the second highest Area (% of total land area) in Arable land?
Keep it short and to the point. 0.08. What is the difference between the highest and the second highest Area (% of total land area) in Permanent crop land?
Provide a succinct answer. 0.01. What is the difference between the highest and the lowest Area (% of total land area) in Terrestrial protected areas?
Make the answer very short. 0.32. What is the difference between the highest and the lowest Area (% of total land area) of Agricultural land?
Ensure brevity in your answer.  0.4. What is the difference between the highest and the lowest Area (% of total land area) in Arable land?
Offer a terse response. 0.33. What is the difference between the highest and the lowest Area (% of total land area) of Permanent crop land?
Keep it short and to the point. 0.07. 